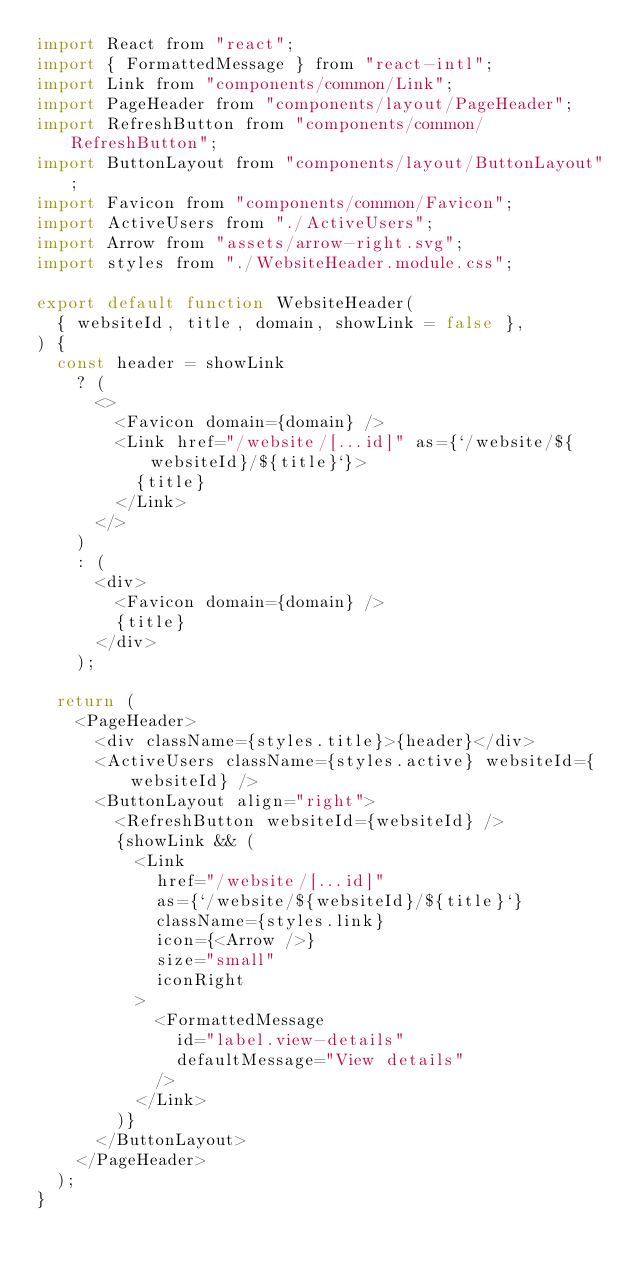<code> <loc_0><loc_0><loc_500><loc_500><_JavaScript_>import React from "react";
import { FormattedMessage } from "react-intl";
import Link from "components/common/Link";
import PageHeader from "components/layout/PageHeader";
import RefreshButton from "components/common/RefreshButton";
import ButtonLayout from "components/layout/ButtonLayout";
import Favicon from "components/common/Favicon";
import ActiveUsers from "./ActiveUsers";
import Arrow from "assets/arrow-right.svg";
import styles from "./WebsiteHeader.module.css";

export default function WebsiteHeader(
  { websiteId, title, domain, showLink = false },
) {
  const header = showLink
    ? (
      <>
        <Favicon domain={domain} />
        <Link href="/website/[...id]" as={`/website/${websiteId}/${title}`}>
          {title}
        </Link>
      </>
    )
    : (
      <div>
        <Favicon domain={domain} />
        {title}
      </div>
    );

  return (
    <PageHeader>
      <div className={styles.title}>{header}</div>
      <ActiveUsers className={styles.active} websiteId={websiteId} />
      <ButtonLayout align="right">
        <RefreshButton websiteId={websiteId} />
        {showLink && (
          <Link
            href="/website/[...id]"
            as={`/website/${websiteId}/${title}`}
            className={styles.link}
            icon={<Arrow />}
            size="small"
            iconRight
          >
            <FormattedMessage
              id="label.view-details"
              defaultMessage="View details"
            />
          </Link>
        )}
      </ButtonLayout>
    </PageHeader>
  );
}
</code> 